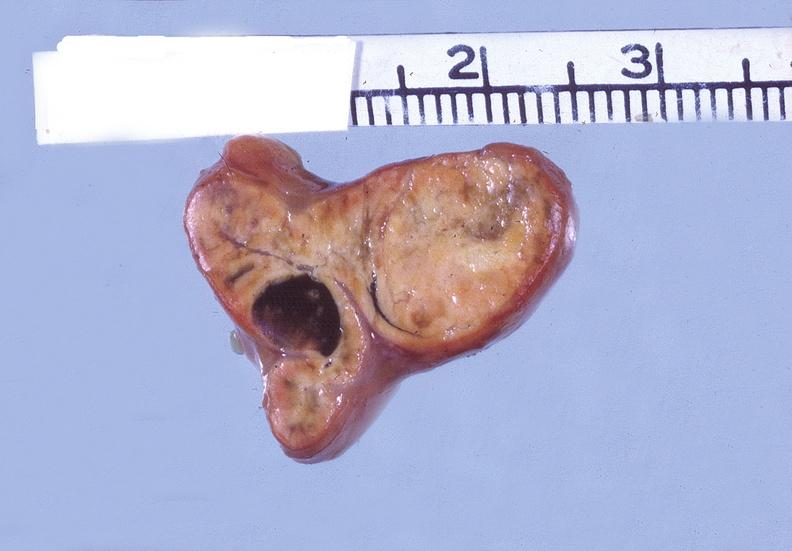s endocrine present?
Answer the question using a single word or phrase. Yes 